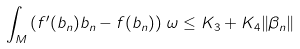Convert formula to latex. <formula><loc_0><loc_0><loc_500><loc_500>\int _ { M } \left ( f ^ { \prime } ( b _ { n } ) b _ { n } - f ( b _ { n } ) \right ) \, \omega \leq K _ { 3 } + K _ { 4 } \| \beta _ { n } \|</formula> 